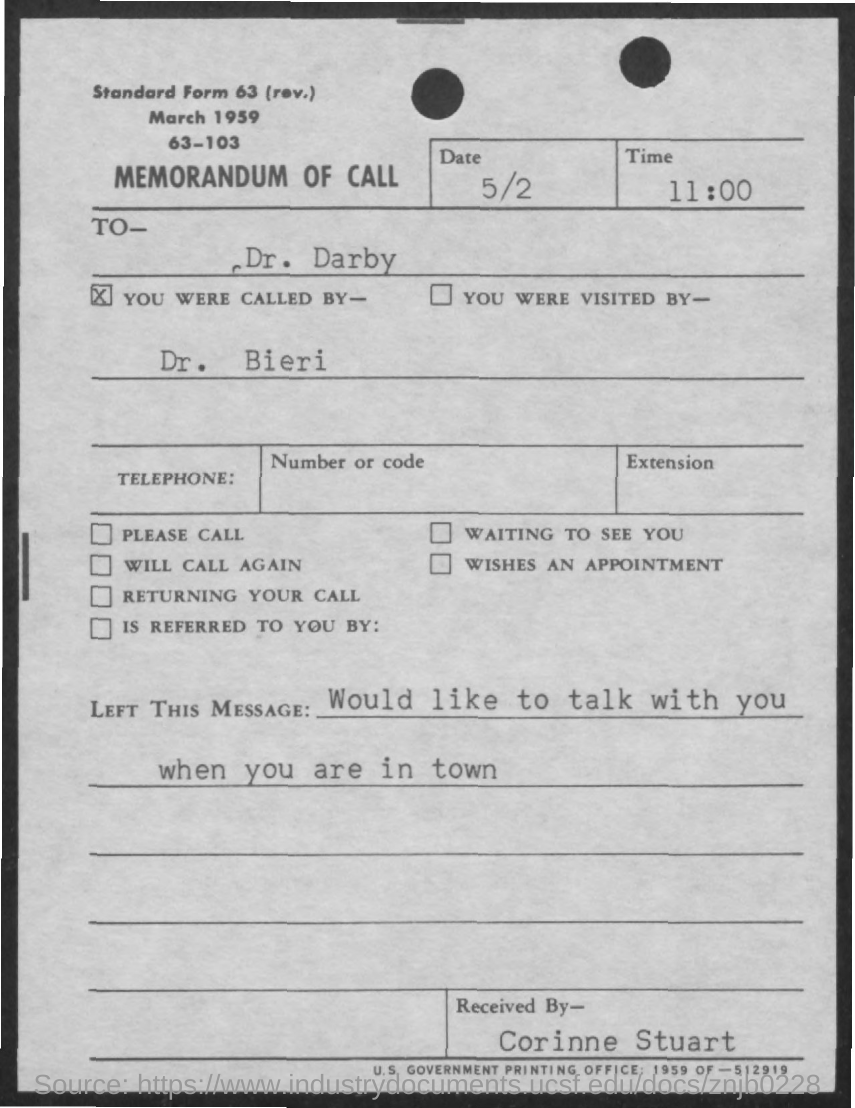What is the title of the document?
Give a very brief answer. MEMORANDUM OF CALL. Whom is the document addressed to?
Offer a very short reply. Dr. Darby. Who called Dr. Darby ?
Your answer should be very brief. Dr. Bieri. What was the message?
Keep it short and to the point. "Would like to talk with you when you are in town". Who received the call?
Keep it short and to the point. Corinne Stuart. 